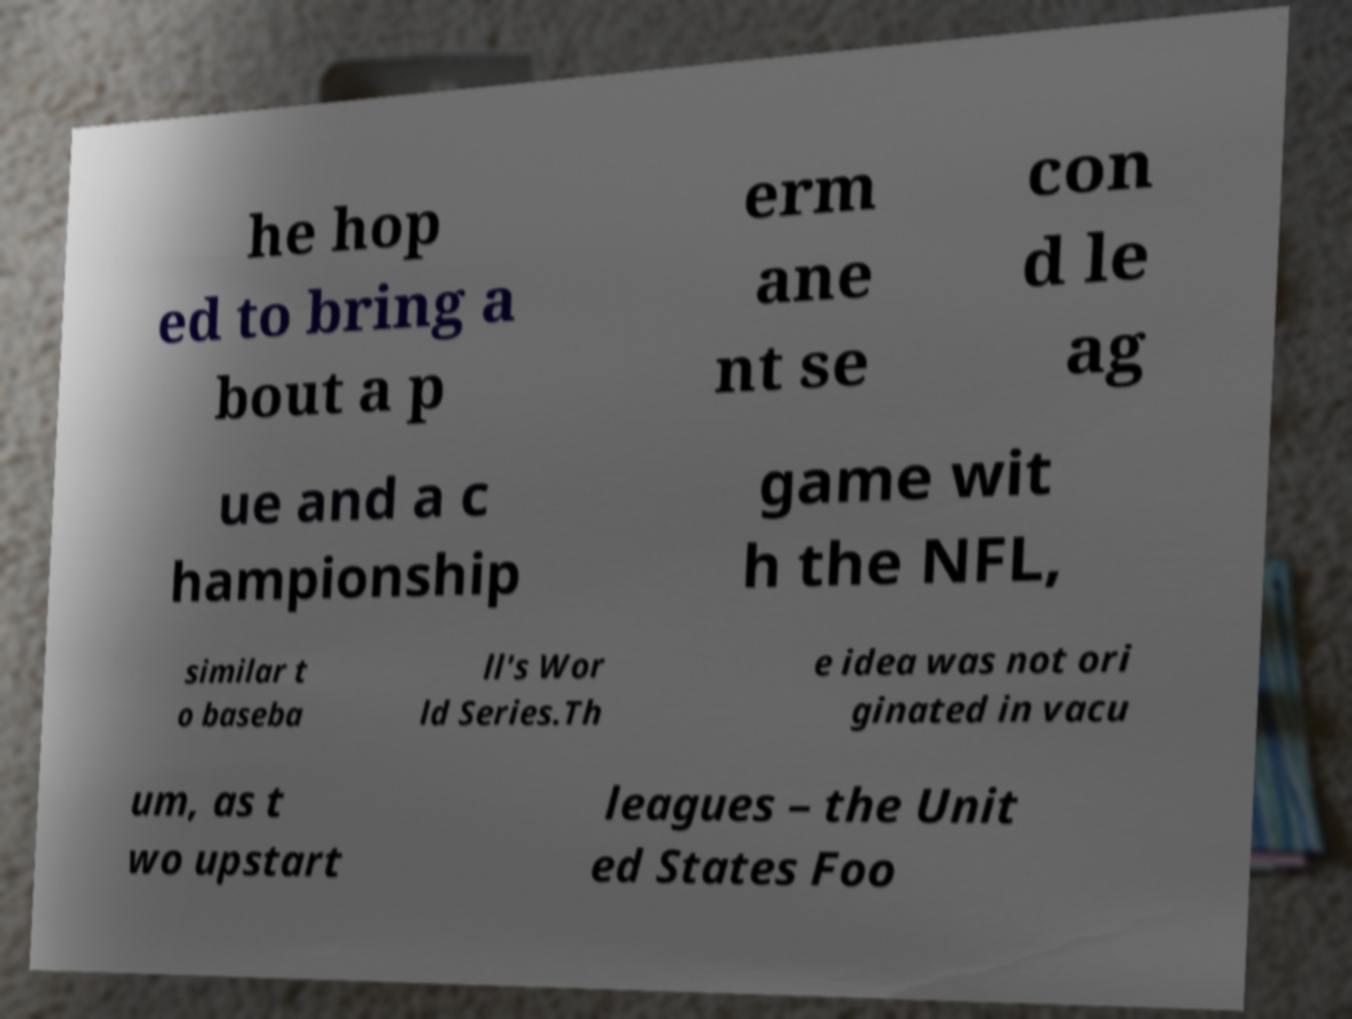I need the written content from this picture converted into text. Can you do that? he hop ed to bring a bout a p erm ane nt se con d le ag ue and a c hampionship game wit h the NFL, similar t o baseba ll's Wor ld Series.Th e idea was not ori ginated in vacu um, as t wo upstart leagues – the Unit ed States Foo 